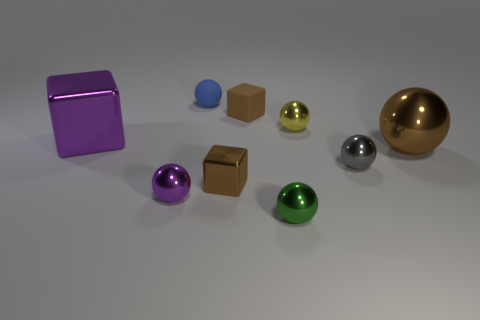Subtract all gray balls. How many balls are left? 5 Subtract all small purple metal balls. How many balls are left? 5 Subtract all yellow balls. Subtract all blue cubes. How many balls are left? 5 Add 1 tiny matte spheres. How many objects exist? 10 Subtract all blocks. How many objects are left? 6 Add 6 tiny green balls. How many tiny green balls are left? 7 Add 6 green rubber cylinders. How many green rubber cylinders exist? 6 Subtract 0 blue cubes. How many objects are left? 9 Subtract all gray balls. Subtract all rubber things. How many objects are left? 6 